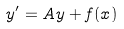<formula> <loc_0><loc_0><loc_500><loc_500>y ^ { \prime } = A y + f ( x )</formula> 